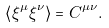Convert formula to latex. <formula><loc_0><loc_0><loc_500><loc_500>\left \langle \xi ^ { \mu } \xi ^ { \nu } \right \rangle = C ^ { \mu \nu } .</formula> 